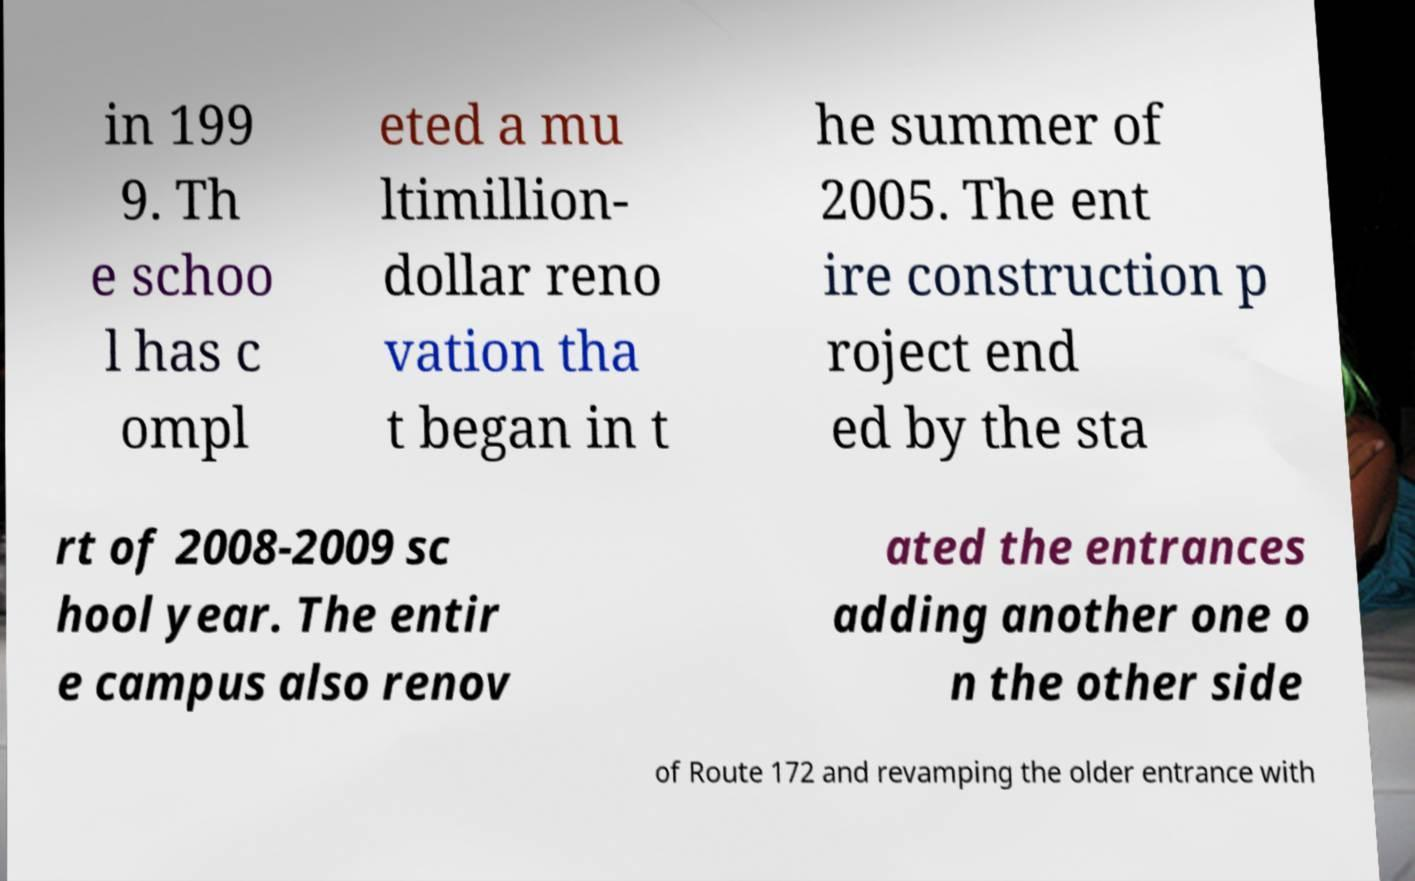What messages or text are displayed in this image? I need them in a readable, typed format. in 199 9. Th e schoo l has c ompl eted a mu ltimillion- dollar reno vation tha t began in t he summer of 2005. The ent ire construction p roject end ed by the sta rt of 2008-2009 sc hool year. The entir e campus also renov ated the entrances adding another one o n the other side of Route 172 and revamping the older entrance with 